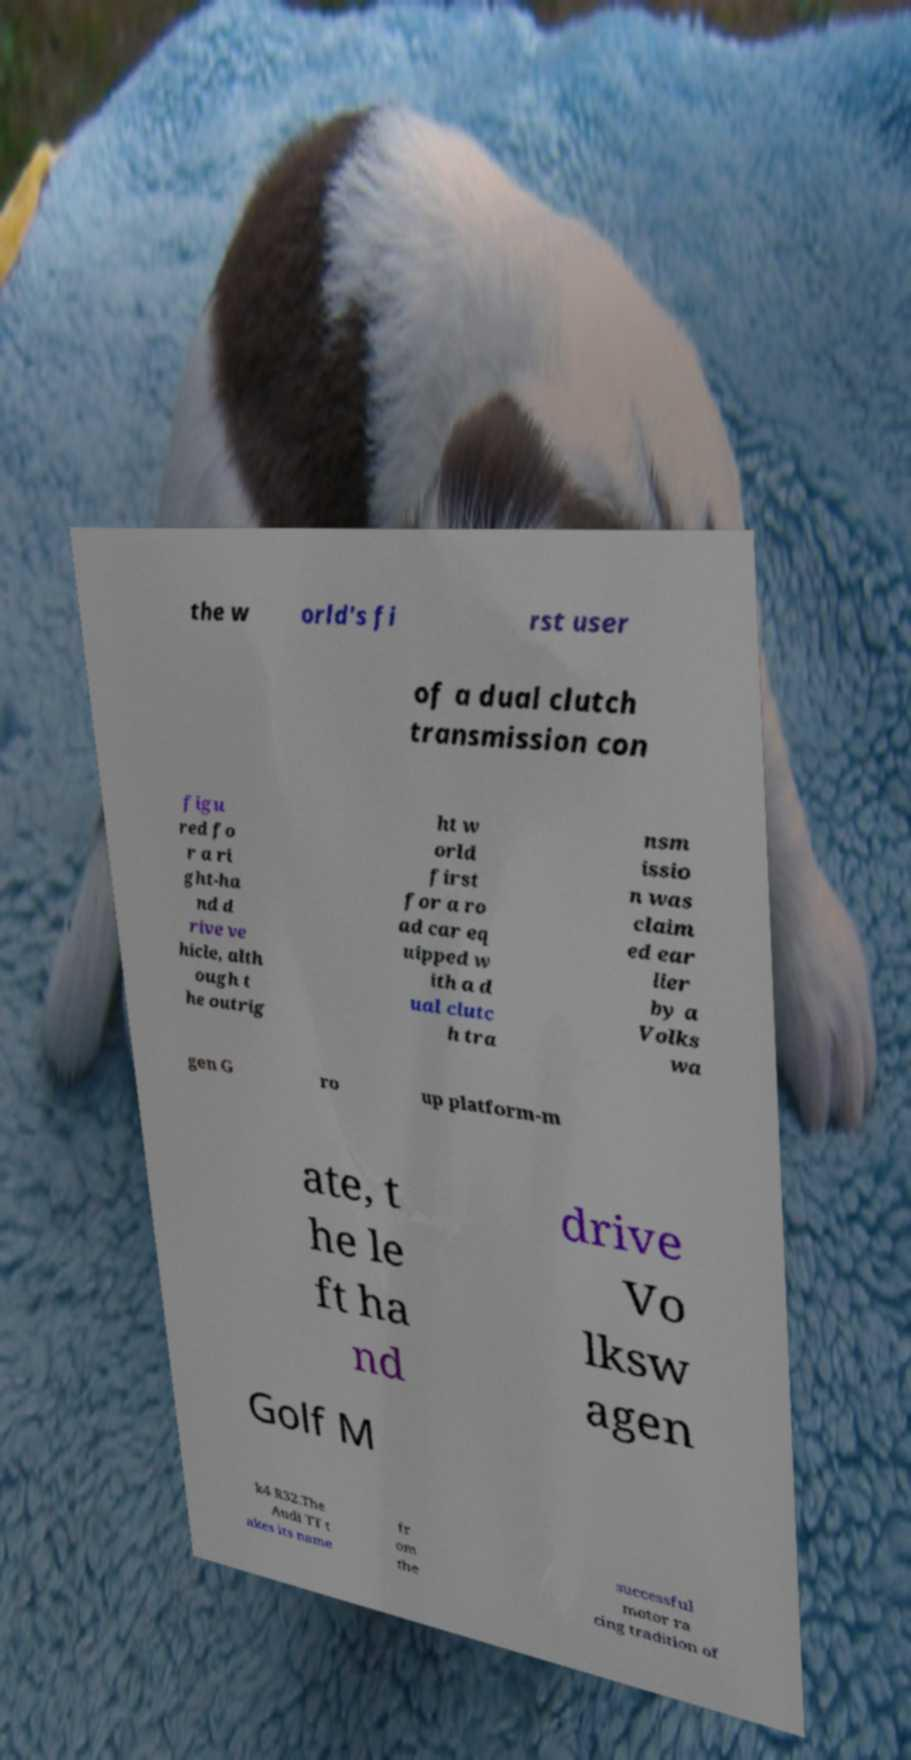Can you accurately transcribe the text from the provided image for me? the w orld's fi rst user of a dual clutch transmission con figu red fo r a ri ght-ha nd d rive ve hicle, alth ough t he outrig ht w orld first for a ro ad car eq uipped w ith a d ual clutc h tra nsm issio n was claim ed ear lier by a Volks wa gen G ro up platform-m ate, t he le ft ha nd drive Vo lksw agen Golf M k4 R32.The Audi TT t akes its name fr om the successful motor ra cing tradition of 